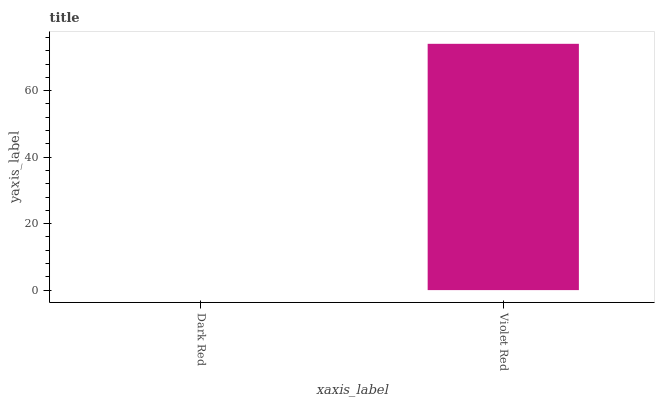Is Violet Red the minimum?
Answer yes or no. No. Is Violet Red greater than Dark Red?
Answer yes or no. Yes. Is Dark Red less than Violet Red?
Answer yes or no. Yes. Is Dark Red greater than Violet Red?
Answer yes or no. No. Is Violet Red less than Dark Red?
Answer yes or no. No. Is Violet Red the high median?
Answer yes or no. Yes. Is Dark Red the low median?
Answer yes or no. Yes. Is Dark Red the high median?
Answer yes or no. No. Is Violet Red the low median?
Answer yes or no. No. 